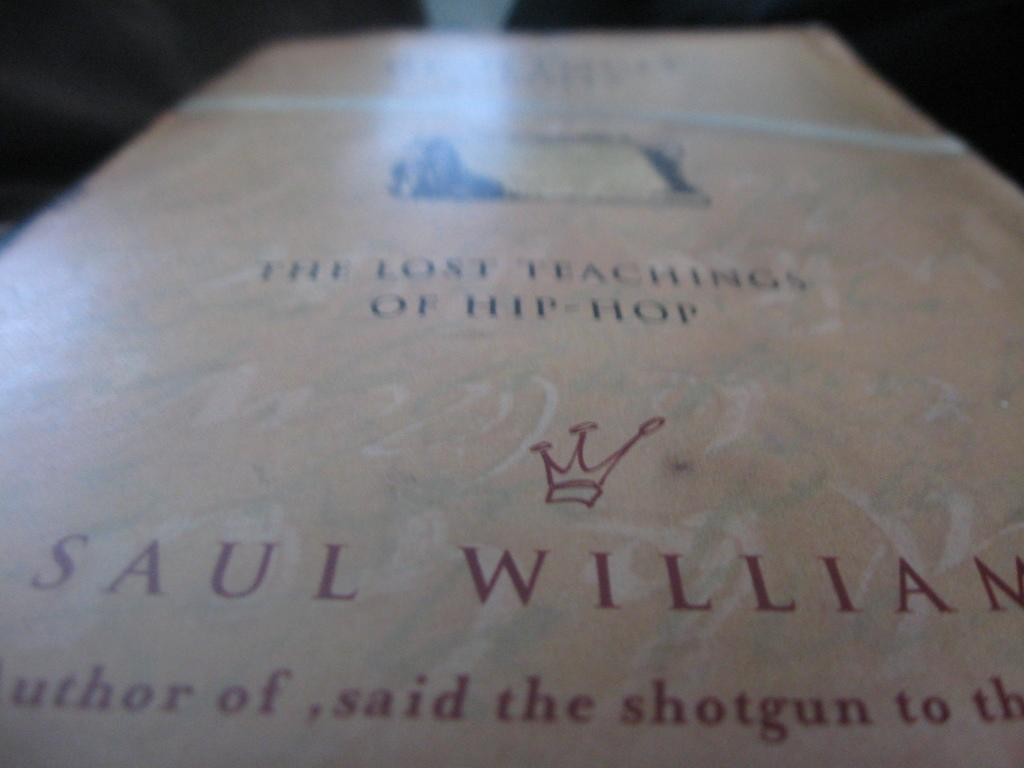<image>
Describe the image concisely. A PAGE IN A BOOK WITH THE AUTHOR Sul william called first teachings of hip hop 